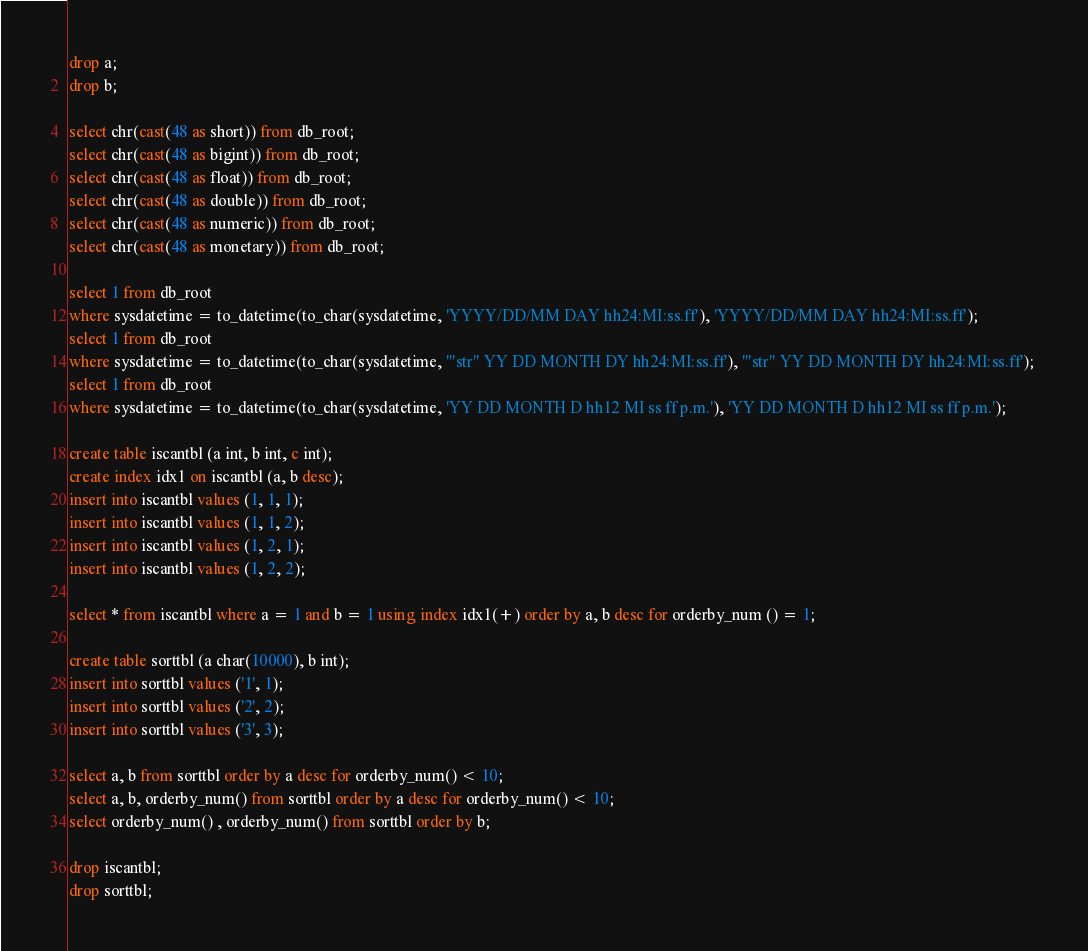<code> <loc_0><loc_0><loc_500><loc_500><_SQL_>drop a;
drop b;

select chr(cast(48 as short)) from db_root;
select chr(cast(48 as bigint)) from db_root;
select chr(cast(48 as float)) from db_root;
select chr(cast(48 as double)) from db_root;
select chr(cast(48 as numeric)) from db_root;
select chr(cast(48 as monetary)) from db_root;

select 1 from db_root
where sysdatetime = to_datetime(to_char(sysdatetime, 'YYYY/DD/MM DAY hh24:MI:ss.ff'), 'YYYY/DD/MM DAY hh24:MI:ss.ff'); 
select 1 from db_root
where sysdatetime = to_datetime(to_char(sysdatetime, '"str" YY DD MONTH DY hh24:MI:ss.ff'), '"str" YY DD MONTH DY hh24:MI:ss.ff'); 
select 1 from db_root
where sysdatetime = to_datetime(to_char(sysdatetime, 'YY DD MONTH D hh12 MI ss ff p.m.'), 'YY DD MONTH D hh12 MI ss ff p.m.');

create table iscantbl (a int, b int, c int);
create index idx1 on iscantbl (a, b desc);
insert into iscantbl values (1, 1, 1);
insert into iscantbl values (1, 1, 2);
insert into iscantbl values (1, 2, 1);
insert into iscantbl values (1, 2, 2);

select * from iscantbl where a = 1 and b = 1 using index idx1(+) order by a, b desc for orderby_num () = 1;

create table sorttbl (a char(10000), b int);
insert into sorttbl values ('1', 1);
insert into sorttbl values ('2', 2);
insert into sorttbl values ('3', 3);

select a, b from sorttbl order by a desc for orderby_num() < 10;
select a, b, orderby_num() from sorttbl order by a desc for orderby_num() < 10;
select orderby_num() , orderby_num() from sorttbl order by b;

drop iscantbl;
drop sorttbl;

</code> 